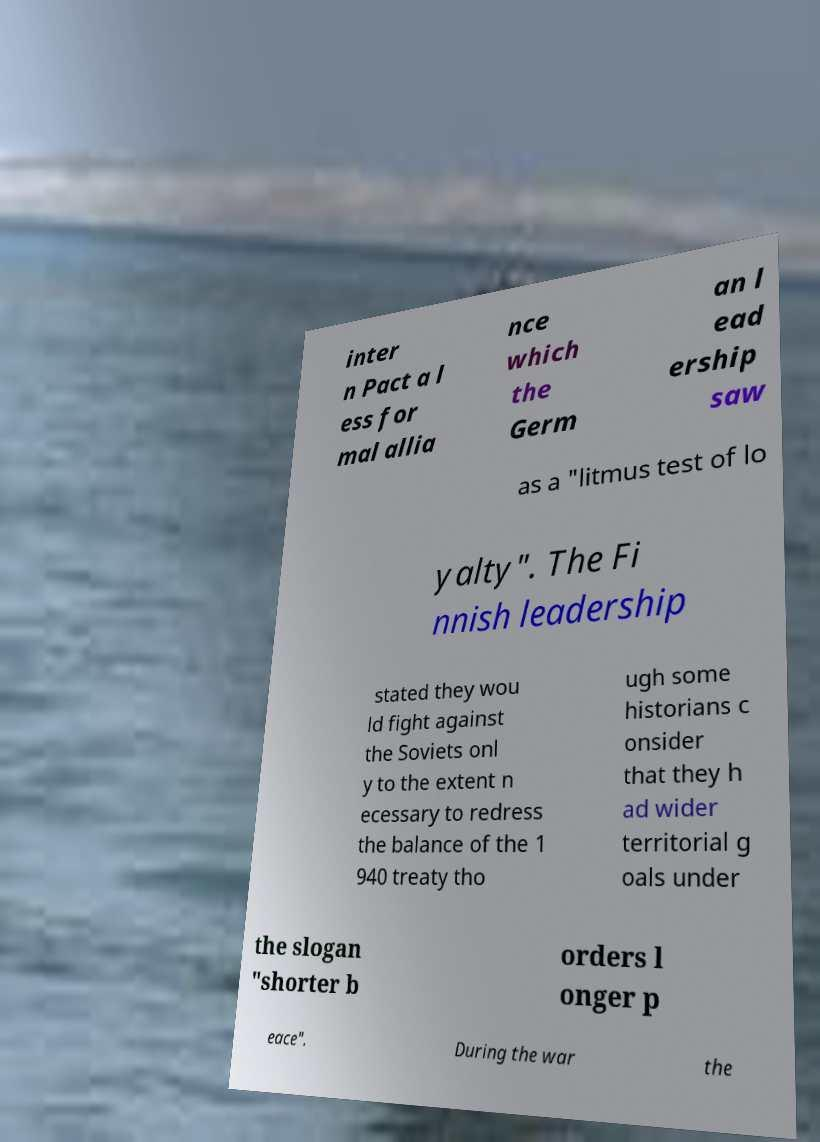Please read and relay the text visible in this image. What does it say? inter n Pact a l ess for mal allia nce which the Germ an l ead ership saw as a "litmus test of lo yalty". The Fi nnish leadership stated they wou ld fight against the Soviets onl y to the extent n ecessary to redress the balance of the 1 940 treaty tho ugh some historians c onsider that they h ad wider territorial g oals under the slogan "shorter b orders l onger p eace". During the war the 